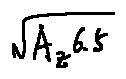<formula> <loc_0><loc_0><loc_500><loc_500>\sqrt { A _ { z } 6 . 5 }</formula> 